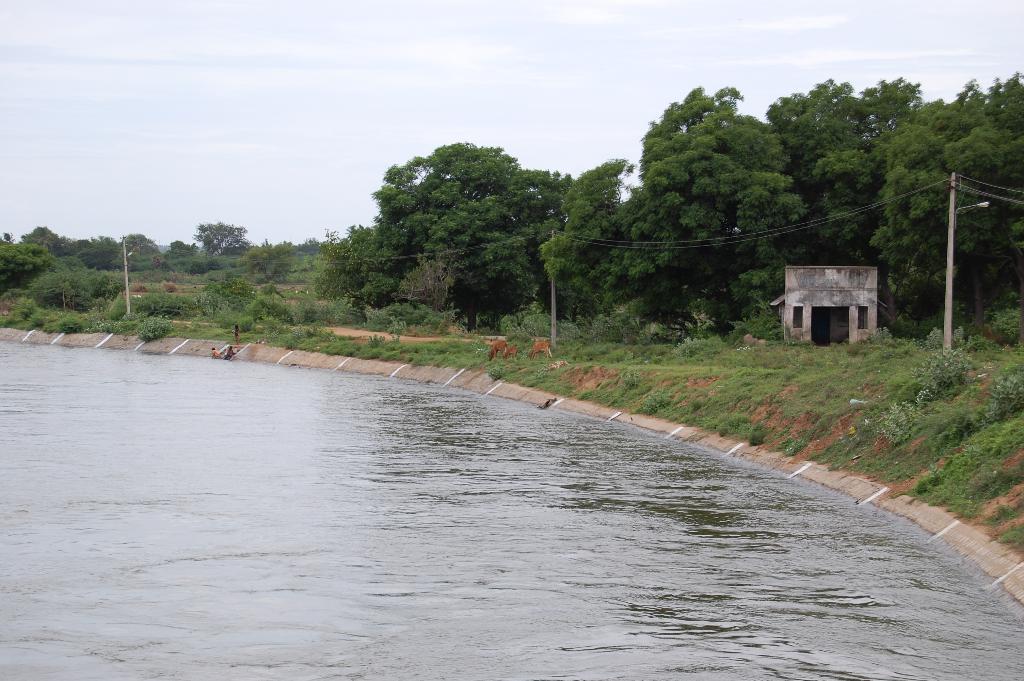How would you summarize this image in a sentence or two? This picture shows few trees and we see water and few plants on the ground and we see a cloudy sky and few poles with lights and we see a house. 